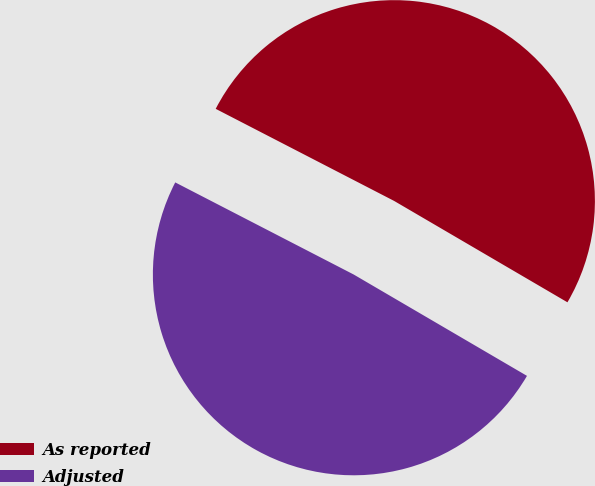Convert chart to OTSL. <chart><loc_0><loc_0><loc_500><loc_500><pie_chart><fcel>As reported<fcel>Adjusted<nl><fcel>50.84%<fcel>49.16%<nl></chart> 